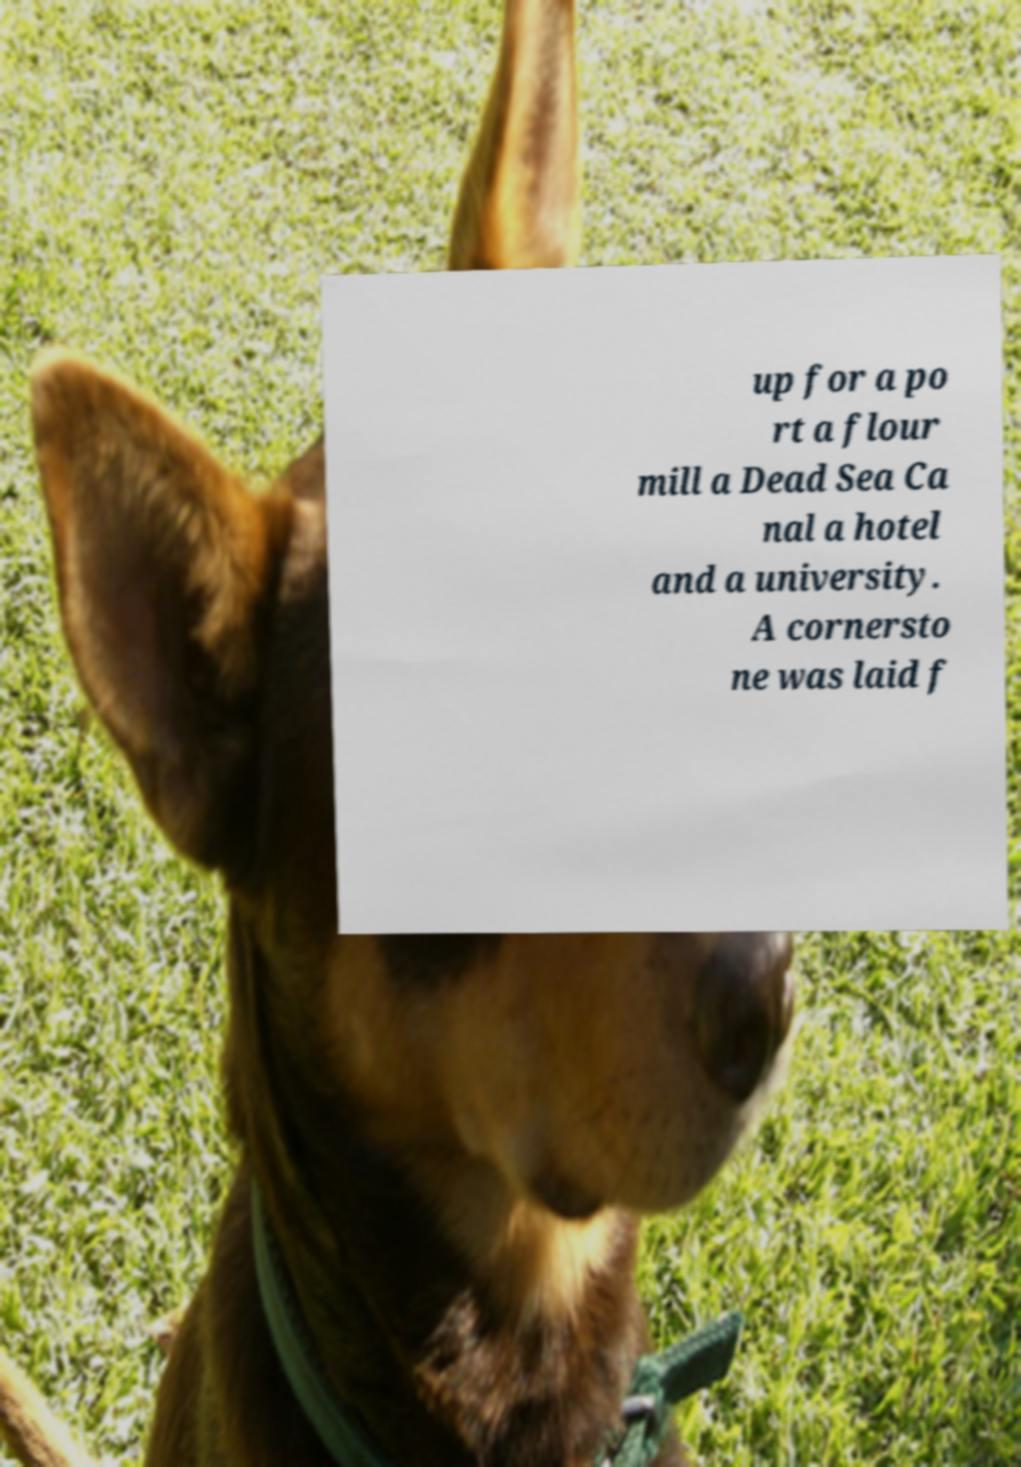Please identify and transcribe the text found in this image. up for a po rt a flour mill a Dead Sea Ca nal a hotel and a university. A cornersto ne was laid f 